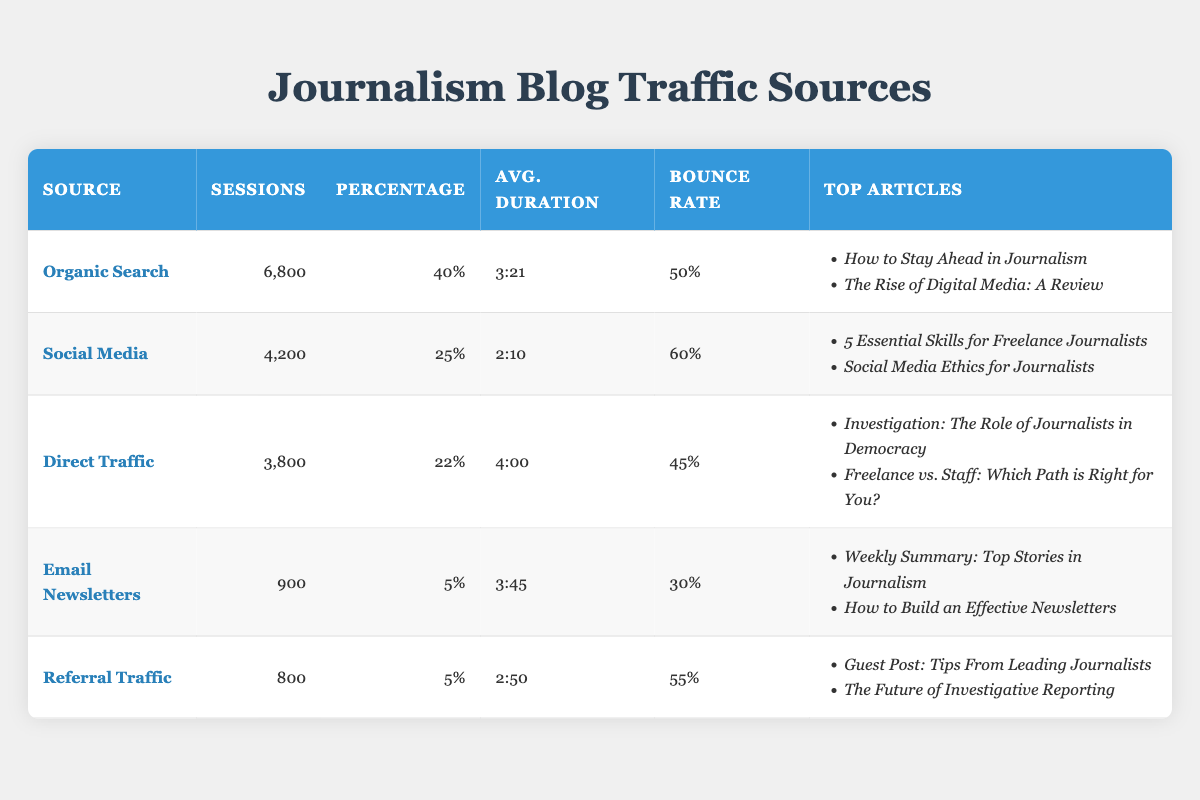What is the source that received the highest number of sessions? By looking at the table, "Organic Search" has the highest number of sessions at 6,800.
Answer: Organic Search What is the average duration of sessions for traffic sources categorized as Social Media? The average duration for Social Media is listed as 2:10.
Answer: 2:10 Which traffic source has the lowest percentage of sessions? The sources with the lowest percentage of sessions are "Email Newsletters" and "Referral Traffic," both at 5%.
Answer: Email Newsletters and Referral Traffic What is the total number of sessions from Direct Traffic and Email Newsletters combined? To calculate the total, add the sessions from Direct Traffic (3,800) and Email Newsletters (900), resulting in 3,800 + 900 = 4,700.
Answer: 4,700 Is the average duration of sessions for Direct Traffic longer than the average duration for Organic Search? The average duration for Direct Traffic is 4:00, while for Organic Search it is 3:21. Since 4:00 is longer than 3:21, the statement is true.
Answer: Yes Which traffic source has the highest bounce rate? The highest bounce rate is found in the Social Media category at 60%.
Answer: Social Media If you sum the sessions of Organic Search and Social Media, what is the total? Adding the sessions for Organic Search (6,800) and Social Media (4,200) gives a total of 6,800 + 4,200 = 11,000 sessions.
Answer: 11,000 Are the top articles for Email Newsletters more focused on career-related topics compared to those of Organic Search? The top articles for Email Newsletters ("Weekly Summary: Top Stories in Journalism" and "How to Build an Effective Newsletters") are less career-focused than those for Organic Search ("How to Stay Ahead in Journalism" and "The Rise of Digital Media: A Review"). Thus, the top articles for Email Newsletters do not directly compare.
Answer: No 